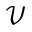<formula> <loc_0><loc_0><loc_500><loc_500>\mathcal { V }</formula> 